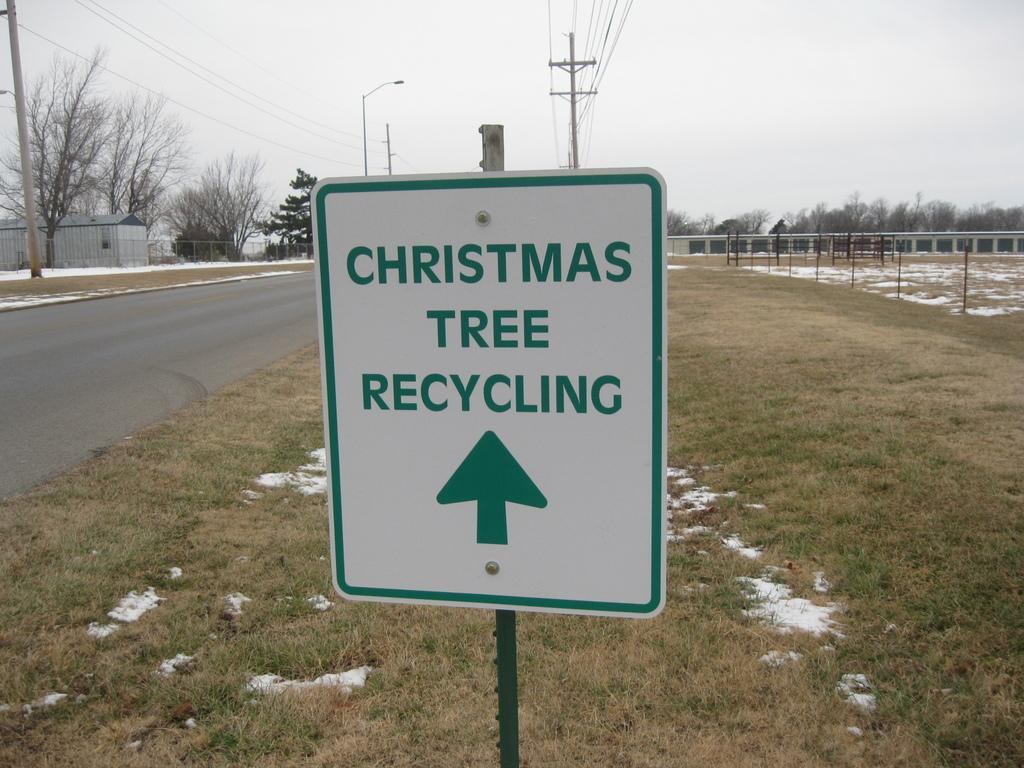Provide a one-sentence caption for the provided image. A sign on the side of the road that says, christmas tree recycling. 